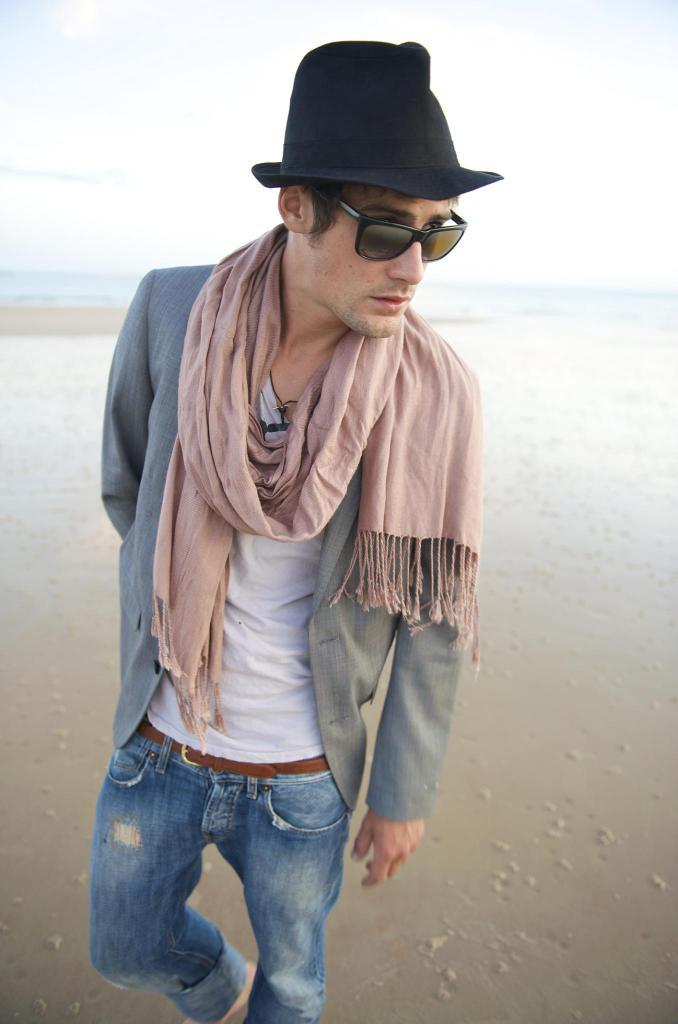What is the main subject of the image? There is a person in the image. What is the person standing on? The person is standing on the sand. What accessory is the person wearing? The person is wearing spectacles. How many cows are visible in the image? There are no cows present in the image; it features a person standing on sand while wearing spectacles. What is the price of the person's finger in the image? There is no price associated with the person's finger in the image, as it is not a commodity for sale. 